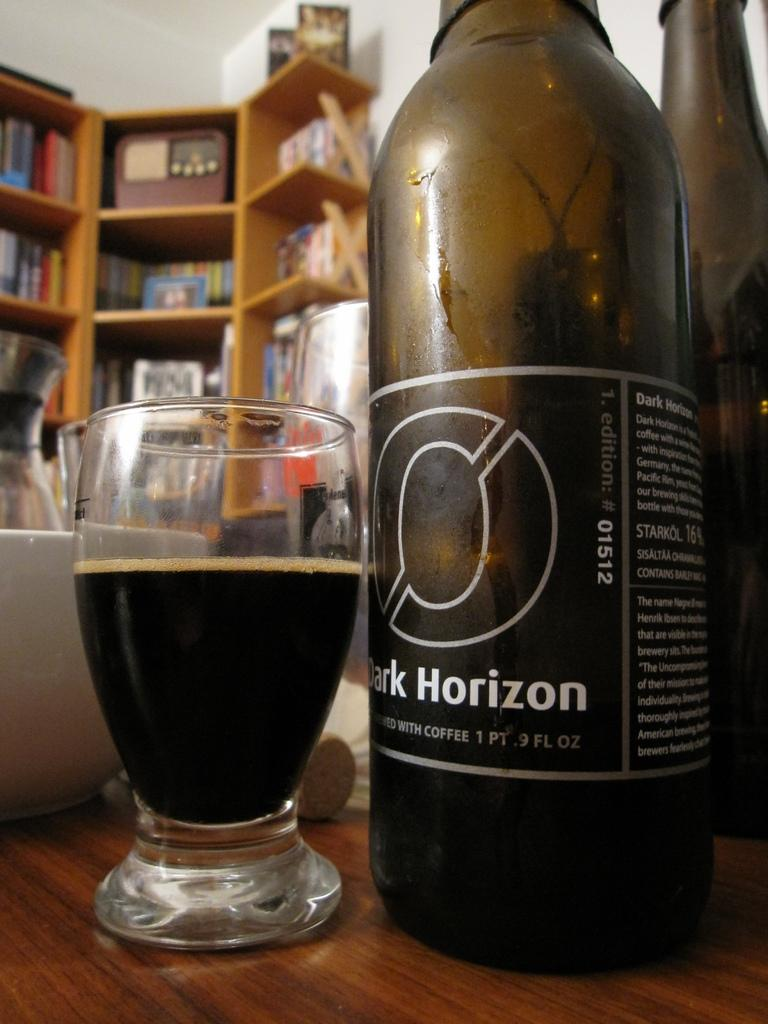<image>
Summarize the visual content of the image. A beer named Dark Horizon that is made with coffee. 